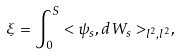Convert formula to latex. <formula><loc_0><loc_0><loc_500><loc_500>\xi = \int _ { 0 } ^ { S } < \psi _ { s } , d W _ { s } > _ { l ^ { 2 } , l ^ { 2 } } ,</formula> 